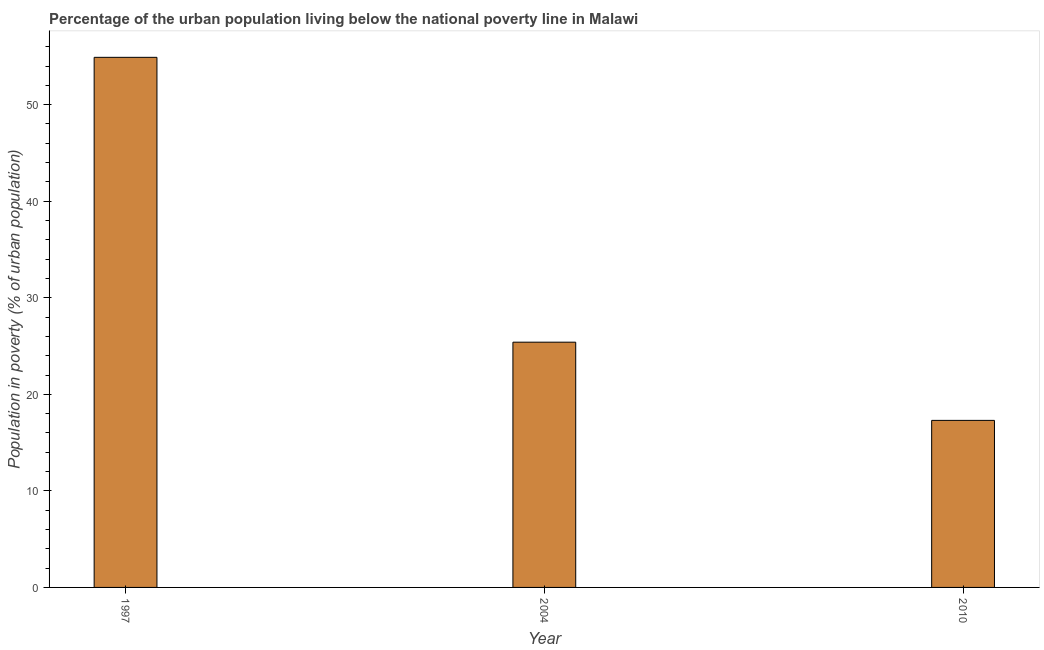Does the graph contain any zero values?
Keep it short and to the point. No. What is the title of the graph?
Your answer should be very brief. Percentage of the urban population living below the national poverty line in Malawi. What is the label or title of the X-axis?
Your response must be concise. Year. What is the label or title of the Y-axis?
Ensure brevity in your answer.  Population in poverty (% of urban population). What is the percentage of urban population living below poverty line in 1997?
Your answer should be very brief. 54.9. Across all years, what is the maximum percentage of urban population living below poverty line?
Ensure brevity in your answer.  54.9. Across all years, what is the minimum percentage of urban population living below poverty line?
Offer a very short reply. 17.3. In which year was the percentage of urban population living below poverty line maximum?
Ensure brevity in your answer.  1997. In which year was the percentage of urban population living below poverty line minimum?
Provide a succinct answer. 2010. What is the sum of the percentage of urban population living below poverty line?
Your answer should be compact. 97.6. What is the difference between the percentage of urban population living below poverty line in 1997 and 2010?
Offer a very short reply. 37.6. What is the average percentage of urban population living below poverty line per year?
Offer a terse response. 32.53. What is the median percentage of urban population living below poverty line?
Make the answer very short. 25.4. In how many years, is the percentage of urban population living below poverty line greater than 44 %?
Offer a very short reply. 1. What is the ratio of the percentage of urban population living below poverty line in 1997 to that in 2010?
Make the answer very short. 3.17. Is the percentage of urban population living below poverty line in 2004 less than that in 2010?
Your response must be concise. No. Is the difference between the percentage of urban population living below poverty line in 1997 and 2004 greater than the difference between any two years?
Your response must be concise. No. What is the difference between the highest and the second highest percentage of urban population living below poverty line?
Make the answer very short. 29.5. What is the difference between the highest and the lowest percentage of urban population living below poverty line?
Your answer should be compact. 37.6. In how many years, is the percentage of urban population living below poverty line greater than the average percentage of urban population living below poverty line taken over all years?
Your response must be concise. 1. How many bars are there?
Keep it short and to the point. 3. How many years are there in the graph?
Keep it short and to the point. 3. Are the values on the major ticks of Y-axis written in scientific E-notation?
Offer a terse response. No. What is the Population in poverty (% of urban population) of 1997?
Offer a terse response. 54.9. What is the Population in poverty (% of urban population) of 2004?
Keep it short and to the point. 25.4. What is the Population in poverty (% of urban population) of 2010?
Offer a terse response. 17.3. What is the difference between the Population in poverty (% of urban population) in 1997 and 2004?
Give a very brief answer. 29.5. What is the difference between the Population in poverty (% of urban population) in 1997 and 2010?
Your response must be concise. 37.6. What is the difference between the Population in poverty (% of urban population) in 2004 and 2010?
Provide a short and direct response. 8.1. What is the ratio of the Population in poverty (% of urban population) in 1997 to that in 2004?
Keep it short and to the point. 2.16. What is the ratio of the Population in poverty (% of urban population) in 1997 to that in 2010?
Provide a short and direct response. 3.17. What is the ratio of the Population in poverty (% of urban population) in 2004 to that in 2010?
Your answer should be very brief. 1.47. 